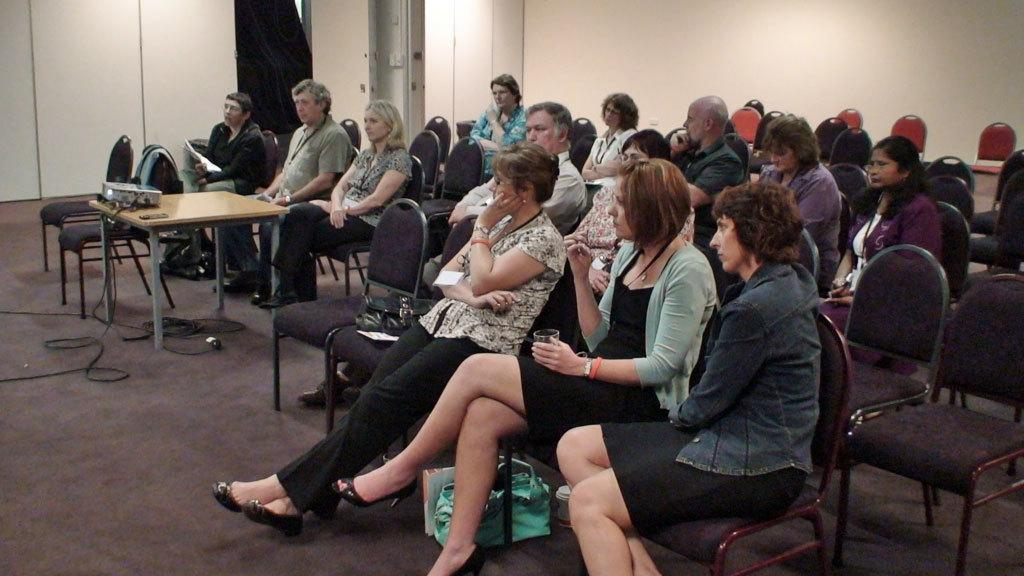What is happening in the image involving a group of people? There is a group of people sitting on chairs in the image. What is present on the table in the image? There is a projector on the table in the image. What can be seen in the background of the image? There is a wall in the background of the image. Can you see any goldfish swimming near the projector in the image? There are no goldfish present in the image. How many toes are visible on the people sitting in the image? The image does not show the toes of the people sitting on the chairs. 